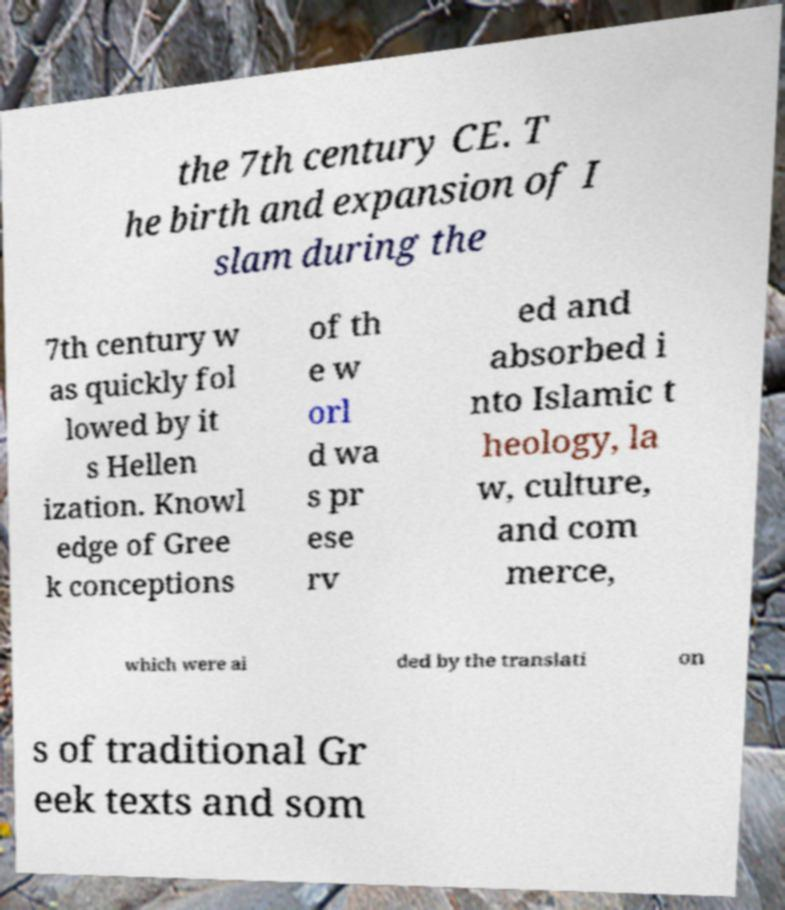Please read and relay the text visible in this image. What does it say? the 7th century CE. T he birth and expansion of I slam during the 7th century w as quickly fol lowed by it s Hellen ization. Knowl edge of Gree k conceptions of th e w orl d wa s pr ese rv ed and absorbed i nto Islamic t heology, la w, culture, and com merce, which were ai ded by the translati on s of traditional Gr eek texts and som 